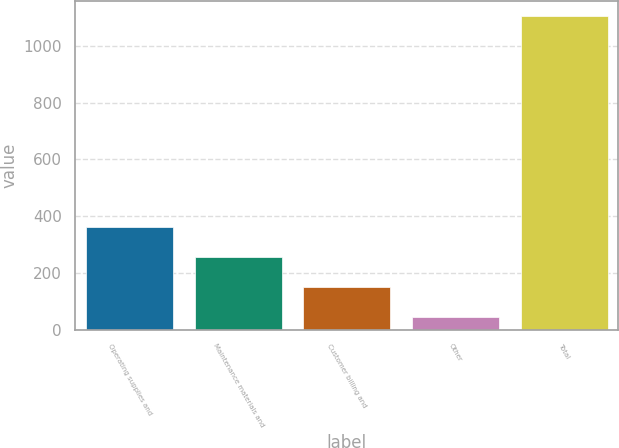<chart> <loc_0><loc_0><loc_500><loc_500><bar_chart><fcel>Operating supplies and<fcel>Maintenance materials and<fcel>Customer billing and<fcel>Other<fcel>Total<nl><fcel>362.3<fcel>256.2<fcel>150.1<fcel>44<fcel>1105<nl></chart> 